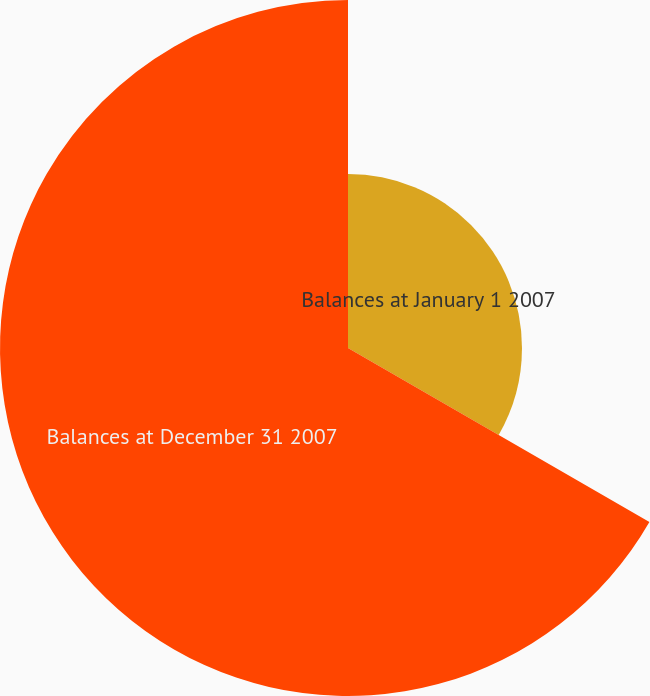Convert chart to OTSL. <chart><loc_0><loc_0><loc_500><loc_500><pie_chart><fcel>Balances at January 1 2007<fcel>Balances at December 31 2007<nl><fcel>33.33%<fcel>66.67%<nl></chart> 